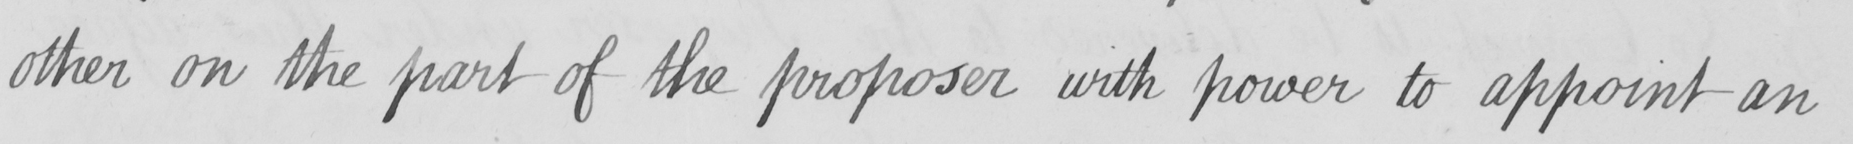What text is written in this handwritten line? other on the part of the proposer with power to appoint an 